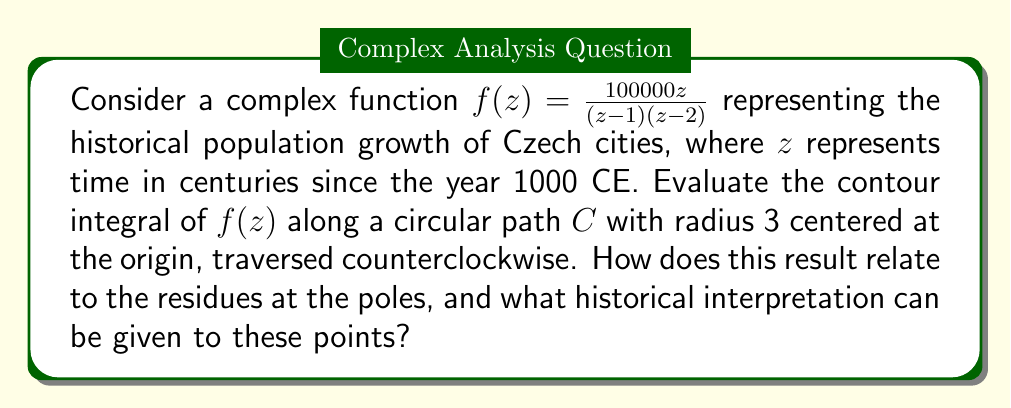Give your solution to this math problem. Let's approach this problem step by step:

1) First, we identify the poles of the function. The poles are at $z=1$ and $z=2$, which both lie within the contour $C$.

2) We can use the Residue Theorem, which states:

   $$\oint_C f(z)dz = 2\pi i \sum \text{Res}(f, a_k)$$

   where $a_k$ are the poles of $f(z)$ inside $C$.

3) To find the residues, we use the formula for simple poles:

   $$\text{Res}(f, a) = \lim_{z \to a} (z-a)f(z)$$

4) For $z=1$:
   $$\text{Res}(f, 1) = \lim_{z \to 1} (z-1)\frac{100000z}{(z-1)(z-2)} = \lim_{z \to 1} \frac{100000z}{z-2} = -100000$$

5) For $z=2$:
   $$\text{Res}(f, 2) = \lim_{z \to 2} (z-2)\frac{100000z}{(z-1)(z-2)} = \lim_{z \to 2} \frac{100000z}{z-1} = 200000$$

6) Applying the Residue Theorem:

   $$\oint_C f(z)dz = 2\pi i (-100000 + 200000) = 2\pi i (100000)$$

7) Historical interpretation:
   - The pole at $z=1$ (year 1100 CE) represents a period of decline, possibly due to conflicts or plagues.
   - The pole at $z=2$ (year 1200 CE) represents a period of growth, possibly due to the founding of new towns and economic development.
   - The net positive result suggests overall growth between these two centuries.
Answer: The contour integral is $200000\pi i$. This result relates to the residues at $z=1$ and $z=2$, which are $-100000$ and $200000$ respectively. Historically, this suggests a period of population decline around 1100 CE followed by significant growth around 1200 CE in Czech cities. 